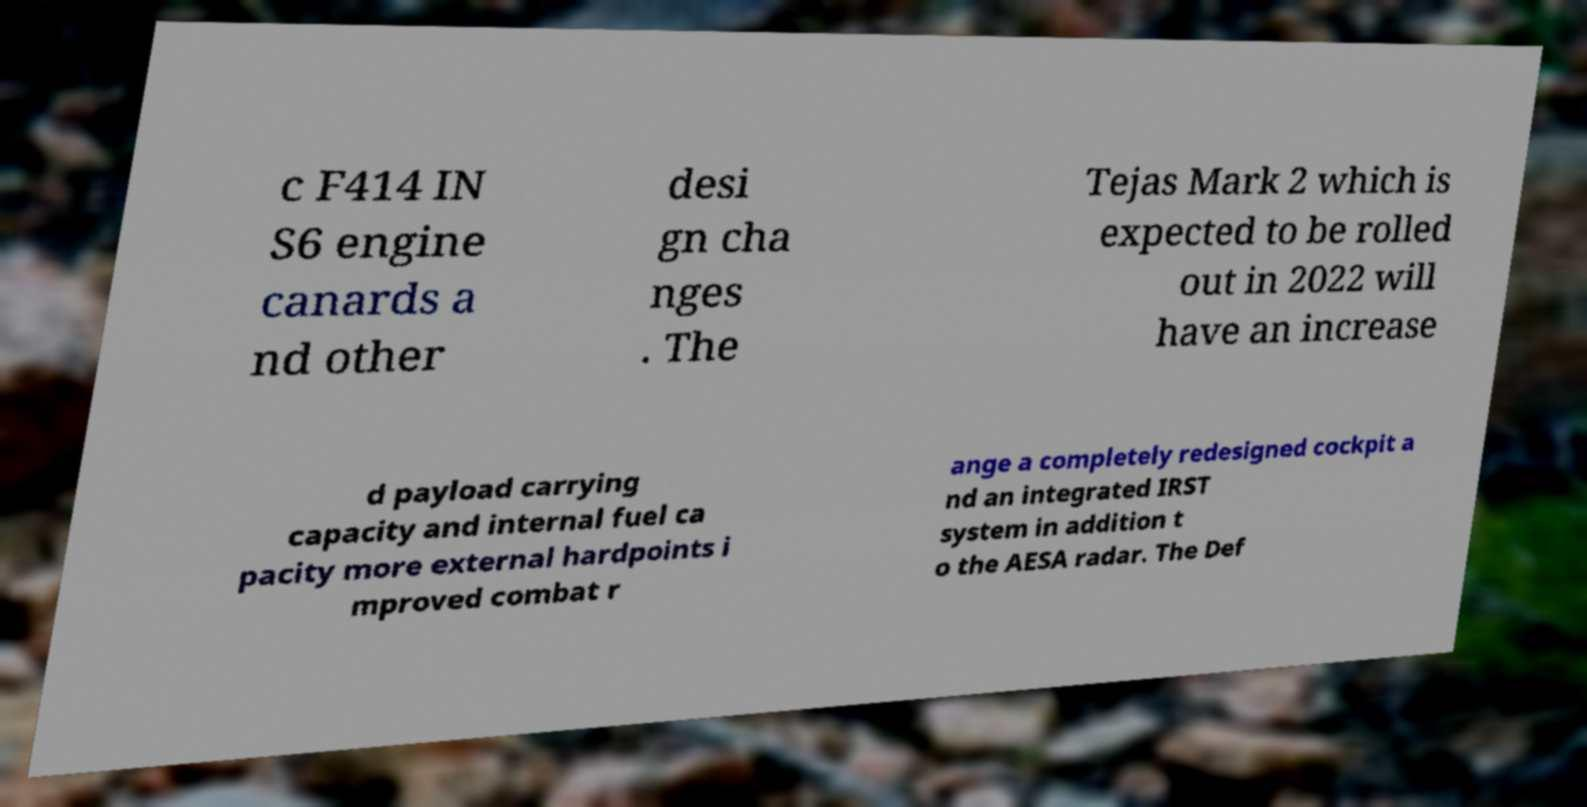Please identify and transcribe the text found in this image. c F414 IN S6 engine canards a nd other desi gn cha nges . The Tejas Mark 2 which is expected to be rolled out in 2022 will have an increase d payload carrying capacity and internal fuel ca pacity more external hardpoints i mproved combat r ange a completely redesigned cockpit a nd an integrated IRST system in addition t o the AESA radar. The Def 